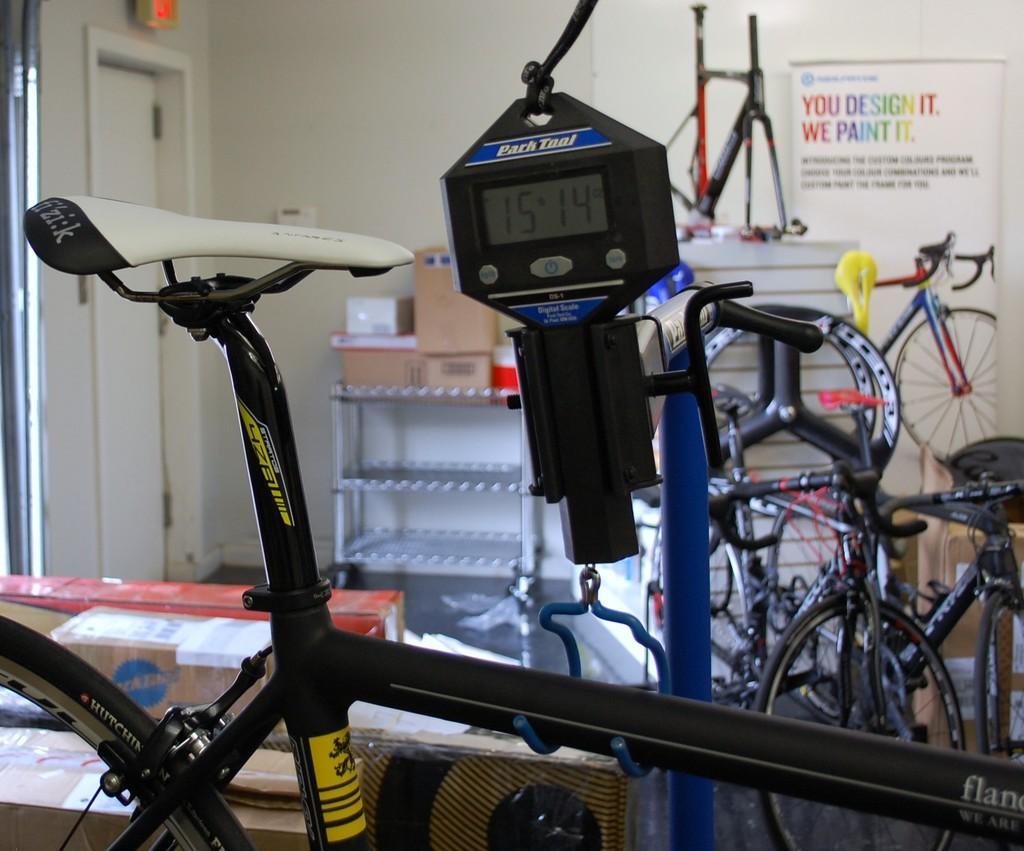How would you summarize this image in a sentence or two? In this image there are cycles, board. There is a rack. On top of the rock there are few objects. On bottom of the image there are few boxes. In the background of the image there is a wall. On the left side of the image there is a door. 